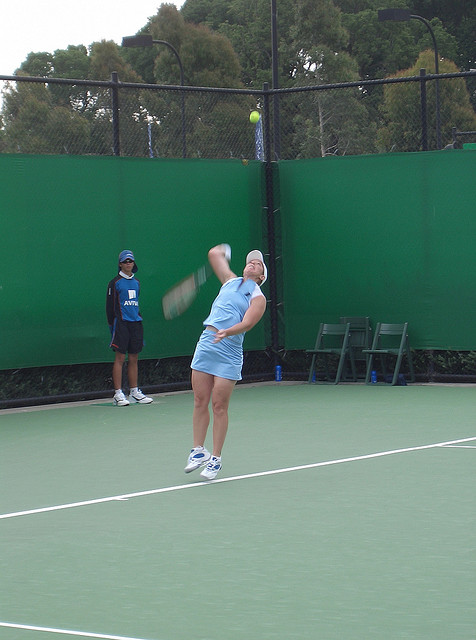Identify the text contained in this image. AVT 